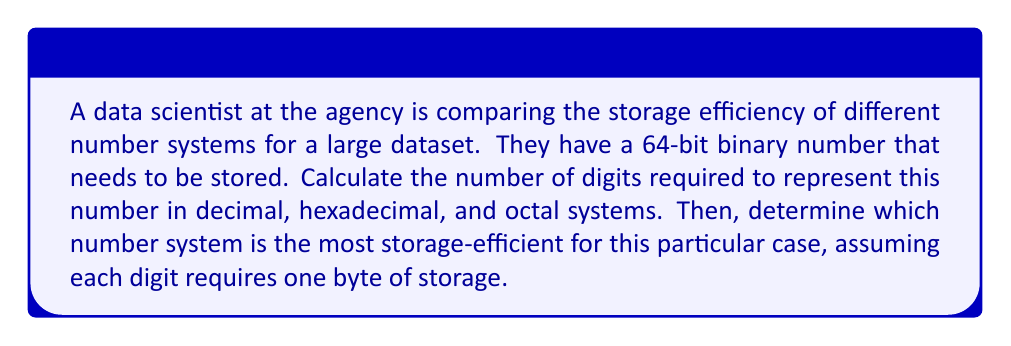Can you solve this math problem? To solve this problem, we need to understand how to convert between number systems and calculate the number of digits required for each representation.

1. Binary to Decimal:
   A 64-bit binary number can represent $2^{64} - 1$ different values.
   The maximum value in decimal is therefore $2^{64} - 1$.
   To find the number of decimal digits, we use the logarithm:
   $$\text{Decimal digits} = \lfloor \log_{10}(2^{64} - 1) \rfloor + 1 \approx 20$$

2. Binary to Hexadecimal:
   Each hexadecimal digit represents 4 bits.
   $$\text{Hexadecimal digits} = \lceil 64 \div 4 \rceil = 16$$

3. Binary to Octal:
   Each octal digit represents 3 bits.
   $$\text{Octal digits} = \lceil 64 \div 3 \rceil = 22$$

Now, to determine which system is most storage-efficient, we compare the number of bytes required to store the number in each system, assuming 1 byte per digit:

- Decimal: 20 bytes
- Hexadecimal: 16 bytes
- Octal: 22 bytes

Therefore, the hexadecimal system is the most storage-efficient for this particular case.
Answer: Hexadecimal is the most storage-efficient, requiring 16 bytes, compared to 20 bytes for decimal and 22 bytes for octal. 